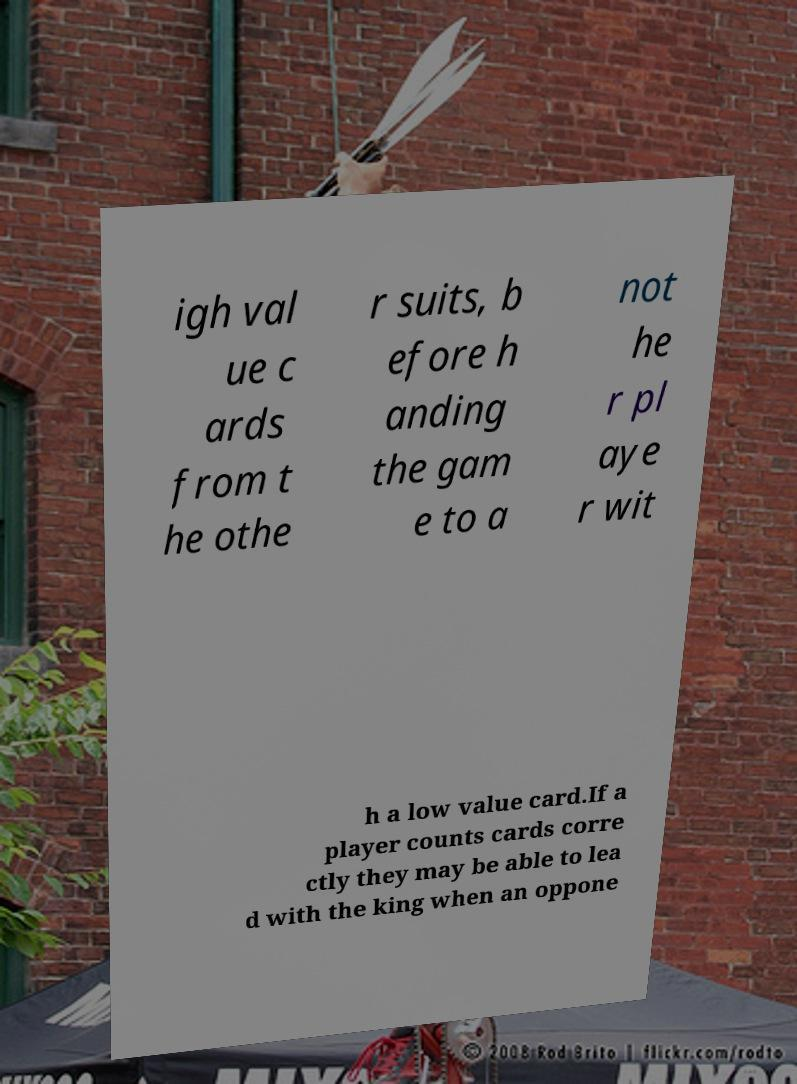What messages or text are displayed in this image? I need them in a readable, typed format. igh val ue c ards from t he othe r suits, b efore h anding the gam e to a not he r pl aye r wit h a low value card.If a player counts cards corre ctly they may be able to lea d with the king when an oppone 